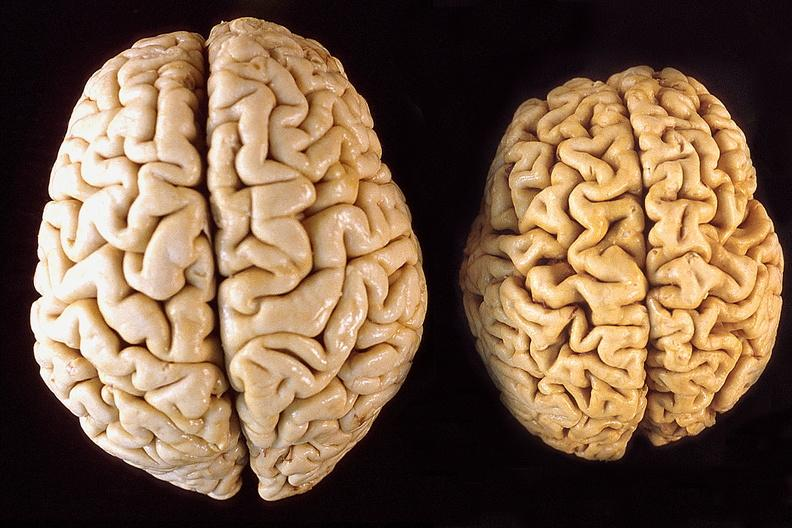what does this image show?
Answer the question using a single word or phrase. Brain 